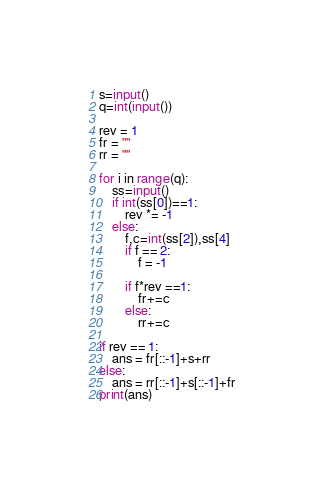<code> <loc_0><loc_0><loc_500><loc_500><_Python_>s=input()
q=int(input())

rev = 1
fr = ""
rr = ""

for i in range(q):
    ss=input()
    if int(ss[0])==1:
        rev *= -1
    else:
        f,c=int(ss[2]),ss[4]
        if f == 2:
            f = -1
        
        if f*rev ==1:
            fr+=c
        else:
            rr+=c

if rev == 1:
    ans = fr[::-1]+s+rr
else:
    ans = rr[::-1]+s[::-1]+fr
print(ans)</code> 